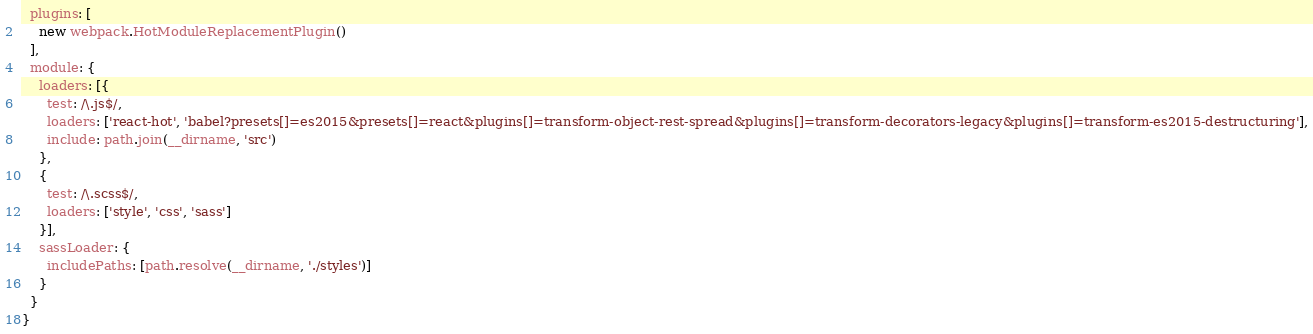Convert code to text. <code><loc_0><loc_0><loc_500><loc_500><_JavaScript_>  plugins: [
    new webpack.HotModuleReplacementPlugin()
  ],
  module: {
    loaders: [{
      test: /\.js$/,
      loaders: ['react-hot', 'babel?presets[]=es2015&presets[]=react&plugins[]=transform-object-rest-spread&plugins[]=transform-decorators-legacy&plugins[]=transform-es2015-destructuring'],
      include: path.join(__dirname, 'src')
    },
    {
      test: /\.scss$/,
      loaders: ['style', 'css', 'sass']
    }],
    sassLoader: {
      includePaths: [path.resolve(__dirname, './styles')]
    }
  }
}
</code> 